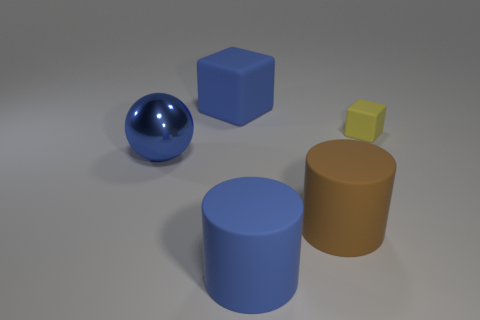Is there any other thing that has the same size as the yellow rubber thing?
Your response must be concise. No. Is there anything else that has the same shape as the big blue metallic object?
Make the answer very short. No. What number of other things are there of the same material as the large sphere
Provide a succinct answer. 0. How many blue objects are either big rubber things or blocks?
Keep it short and to the point. 2. What number of yellow rubber cubes have the same size as the brown object?
Your answer should be very brief. 0. The metallic thing that is the same color as the big matte block is what shape?
Give a very brief answer. Sphere. What number of objects are either blue rubber objects or matte cylinders behind the blue cylinder?
Provide a succinct answer. 3. Is the size of the rubber cube that is behind the tiny yellow object the same as the blue object in front of the blue shiny thing?
Your answer should be very brief. Yes. What number of blue metallic things have the same shape as the brown object?
Make the answer very short. 0. What is the shape of the brown thing that is the same material as the blue block?
Your answer should be compact. Cylinder. 